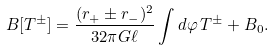<formula> <loc_0><loc_0><loc_500><loc_500>B [ T ^ { \pm } ] = \frac { ( r _ { + } \pm r _ { - } ) ^ { 2 } } { 3 2 \pi G \ell } \int d \varphi \, T ^ { \pm } + B _ { 0 } .</formula> 